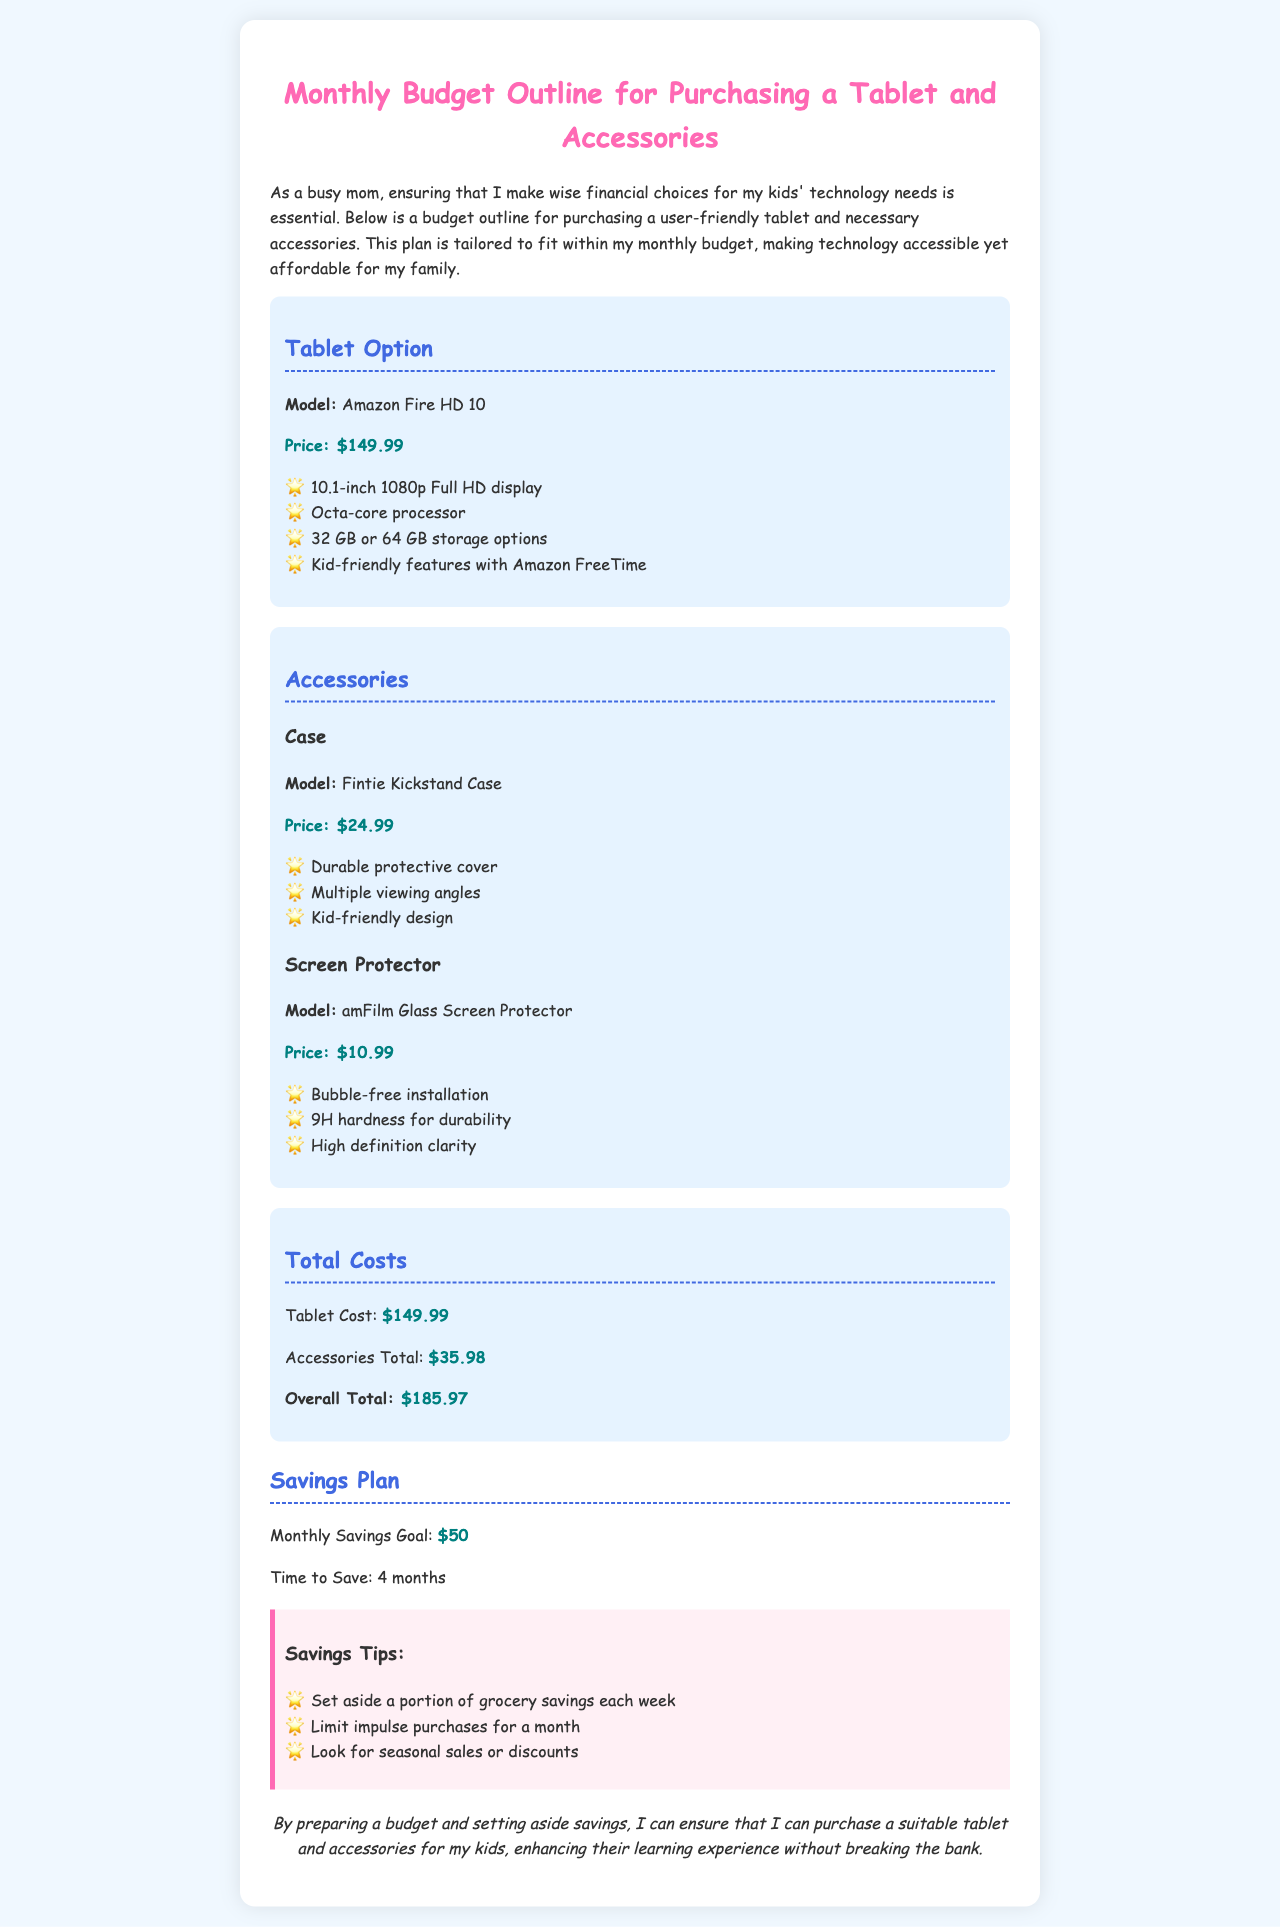What is the tablet model mentioned? The tablet model is specified in the document under the Tablet Option section, which is the Amazon Fire HD 10.
Answer: Amazon Fire HD 10 What is the price of the tablet? The price of the tablet is listed right below the model in the Tablet Option section, which is $149.99.
Answer: $149.99 How much is the Fintie Kickstand Case? The price of the Fintie Kickstand Case is provided in the Accessories section, which is $24.99.
Answer: $24.99 What is the overall total cost for the tablet and accessories? The overall total is calculated under the Total Costs section by adding the tablet cost and accessories total, which sums up to $185.97.
Answer: $185.97 How long will it take to save for the tablet? The document mentions a specific time frame for saving in the Savings Plan section, which is 4 months.
Answer: 4 months What is the monthly savings goal? The document states the monthly savings goal in the Savings Plan section, which is $50.
Answer: $50 Which accessory has a 9H hardness for durability? The amFilm Glass Screen Protector is mentioned to have a 9H hardness in the Accessories section.
Answer: amFilm Glass Screen Protector What is one of the savings tips mentioned? The document lists savings tips in the Savings Tips section, one of which is to set aside a portion of grocery savings each week.
Answer: Set aside a portion of grocery savings each week What is the storage option available for the tablet? The available storage options  are listed under the Tablet Option section, which are 32 GB or 64 GB.
Answer: 32 GB or 64 GB 